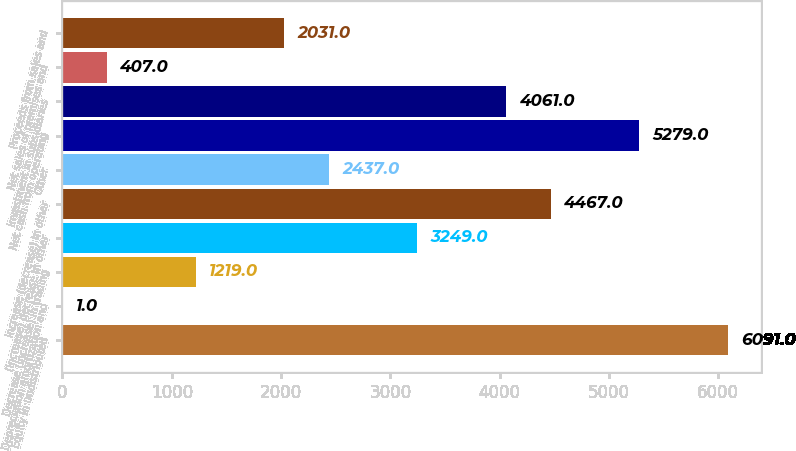<chart> <loc_0><loc_0><loc_500><loc_500><bar_chart><fcel>Equity in undistributed<fcel>Depreciation amortization and<fcel>Decrease (increase) in trading<fcel>(Increase) decrease in other<fcel>Increase (decrease) in other<fcel>Other<fcel>Net cash from operating<fcel>Investment in subsidiaries<fcel>Net sales of premises and<fcel>Proceeds from sales and<nl><fcel>6091<fcel>1<fcel>1219<fcel>3249<fcel>4467<fcel>2437<fcel>5279<fcel>4061<fcel>407<fcel>2031<nl></chart> 